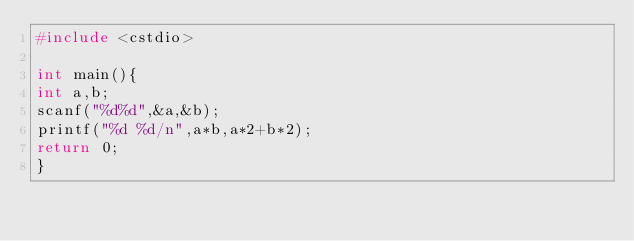Convert code to text. <code><loc_0><loc_0><loc_500><loc_500><_C++_>#include <cstdio>
    
int main(){
int a,b;
scanf("%d%d",&a,&b);
printf("%d %d/n",a*b,a*2+b*2);
return 0;
}</code> 